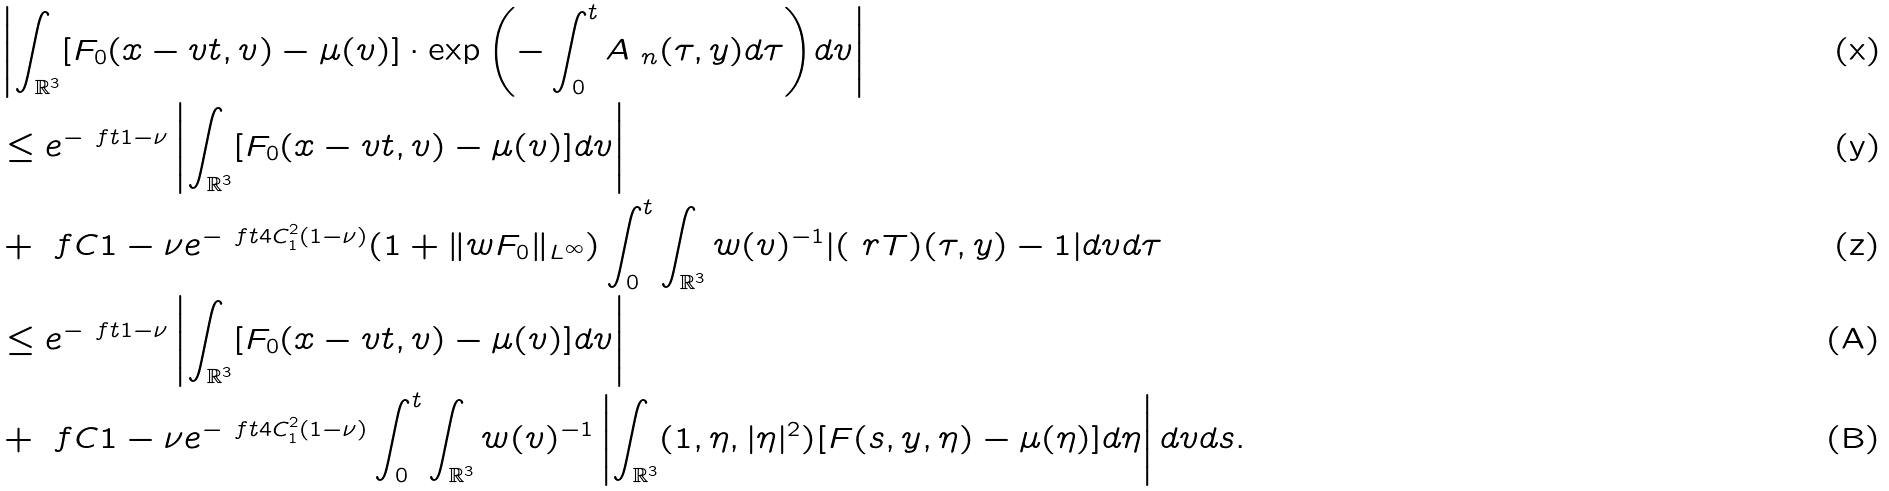<formula> <loc_0><loc_0><loc_500><loc_500>& \left | \int _ { \mathbb { R } ^ { 3 } } [ F _ { 0 } ( x - v t , v ) - \mu ( v ) ] \cdot \exp { \left ( - \int _ { 0 } ^ { t } A _ { \ n } ( \tau , y ) d \tau \right ) } d v \right | \\ & \leq e ^ { - \ f { t } { 1 - \nu } } \left | \int _ { \mathbb { R } ^ { 3 } } [ F _ { 0 } ( x - v t , v ) - \mu ( v ) ] d v \right | \\ & + \ f { C } { 1 - \nu } e ^ { - \ f { t } { 4 C ^ { 2 } _ { 1 } ( 1 - \nu ) } } ( 1 + \| w F _ { 0 } \| _ { L ^ { \infty } } ) \int _ { 0 } ^ { t } \int _ { \mathbb { R } ^ { 3 } } w ( v ) ^ { - 1 } | ( \ r T ) ( \tau , y ) - 1 | d v d \tau \\ & \leq e ^ { - \ f { t } { 1 - \nu } } \left | \int _ { \mathbb { R } ^ { 3 } } [ F _ { 0 } ( x - v t , v ) - \mu ( v ) ] d v \right | \\ & + \ f { C } { 1 - \nu } e ^ { - \ f { t } { 4 C ^ { 2 } _ { 1 } ( 1 - \nu ) } } \int _ { 0 } ^ { t } \int _ { \mathbb { R } ^ { 3 } } w ( v ) ^ { - 1 } \left | \int _ { \mathbb { R } ^ { 3 } } ( 1 , \eta , | \eta | ^ { 2 } ) [ F ( s , y , \eta ) - \mu ( \eta ) ] d \eta \right | d v d s .</formula> 